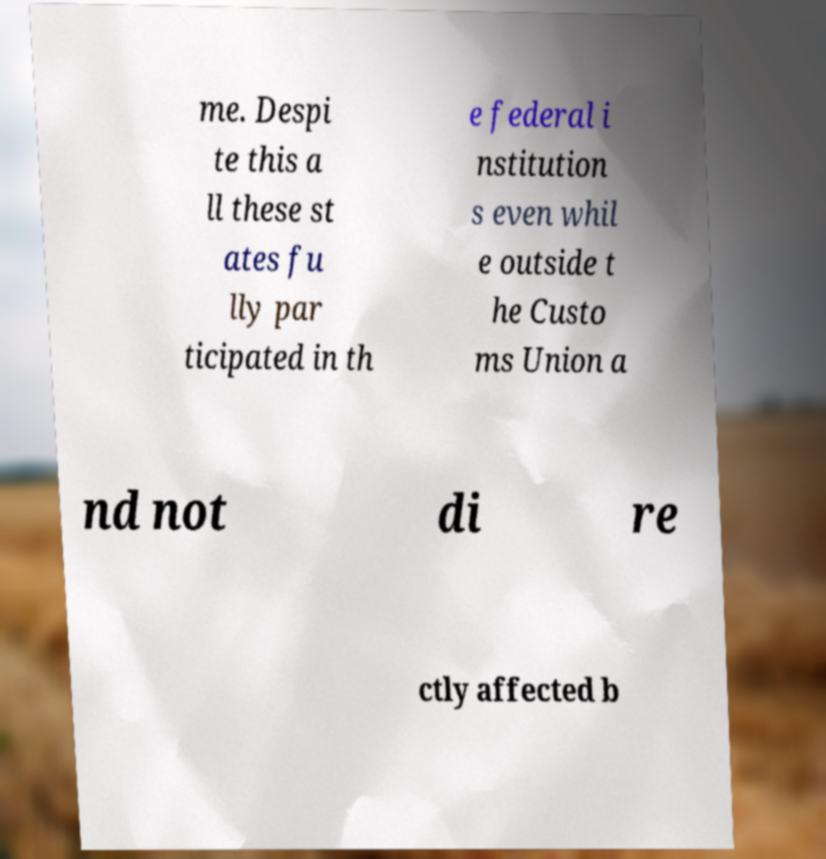What messages or text are displayed in this image? I need them in a readable, typed format. me. Despi te this a ll these st ates fu lly par ticipated in th e federal i nstitution s even whil e outside t he Custo ms Union a nd not di re ctly affected b 